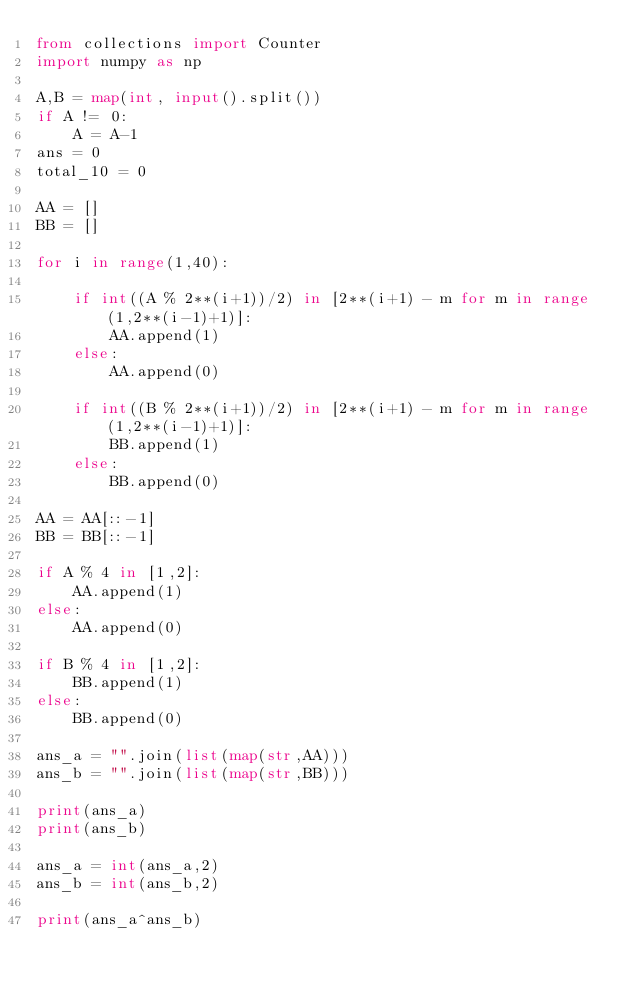<code> <loc_0><loc_0><loc_500><loc_500><_Python_>from collections import Counter
import numpy as np

A,B = map(int, input().split())
if A != 0:
    A = A-1
ans = 0
total_10 = 0

AA = []
BB = []

for i in range(1,40):

    if int((A % 2**(i+1))/2) in [2**(i+1) - m for m in range(1,2**(i-1)+1)]:
        AA.append(1)
    else:
        AA.append(0)

    if int((B % 2**(i+1))/2) in [2**(i+1) - m for m in range(1,2**(i-1)+1)]:
        BB.append(1)
    else:
        BB.append(0)

AA = AA[::-1]
BB = BB[::-1]

if A % 4 in [1,2]:
    AA.append(1)
else:
    AA.append(0)

if B % 4 in [1,2]:
    BB.append(1)
else:
    BB.append(0)

ans_a = "".join(list(map(str,AA)))
ans_b = "".join(list(map(str,BB)))

print(ans_a)
print(ans_b)

ans_a = int(ans_a,2)
ans_b = int(ans_b,2)

print(ans_a^ans_b)</code> 